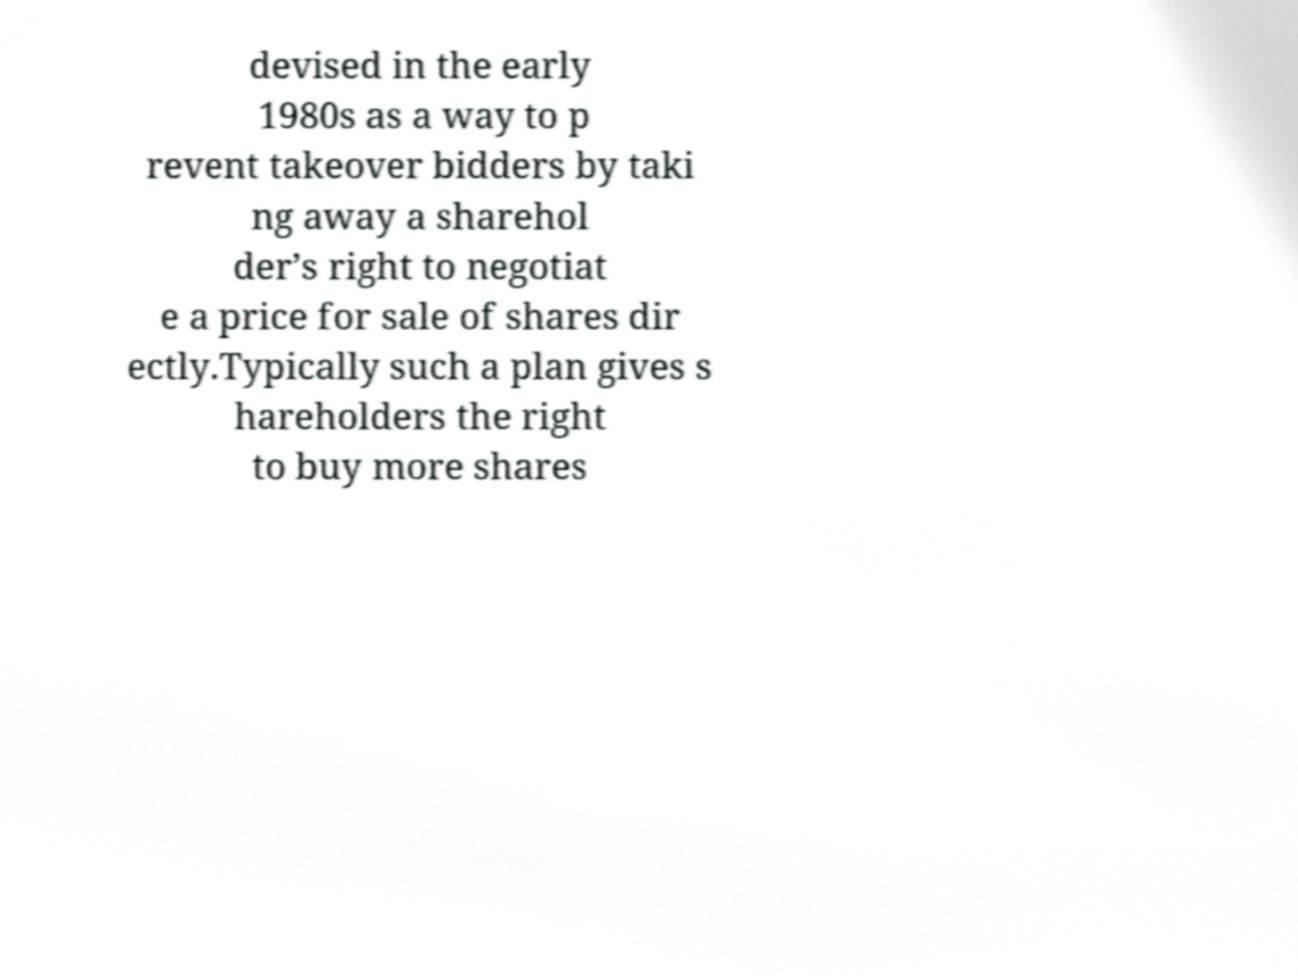Can you read and provide the text displayed in the image?This photo seems to have some interesting text. Can you extract and type it out for me? devised in the early 1980s as a way to p revent takeover bidders by taki ng away a sharehol der’s right to negotiat e a price for sale of shares dir ectly.Typically such a plan gives s hareholders the right to buy more shares 